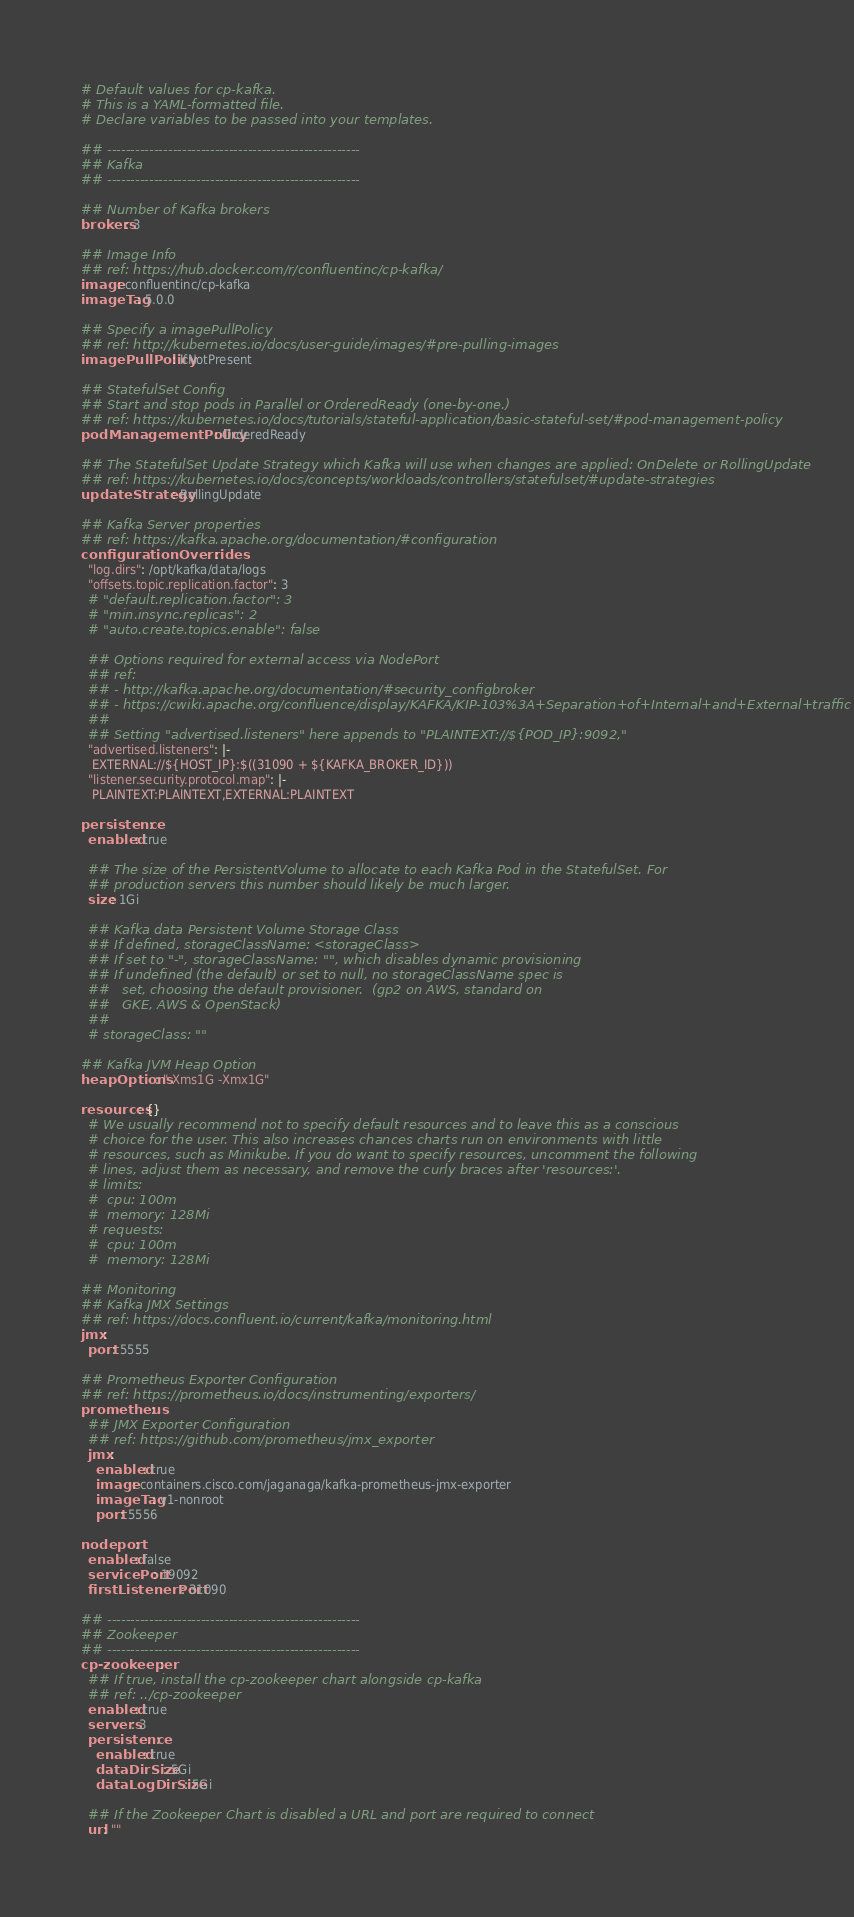<code> <loc_0><loc_0><loc_500><loc_500><_YAML_># Default values for cp-kafka.
# This is a YAML-formatted file.
# Declare variables to be passed into your templates.

## ------------------------------------------------------
## Kafka
## ------------------------------------------------------

## Number of Kafka brokers
brokers: 3

## Image Info
## ref: https://hub.docker.com/r/confluentinc/cp-kafka/
image: confluentinc/cp-kafka
imageTag: 5.0.0

## Specify a imagePullPolicy
## ref: http://kubernetes.io/docs/user-guide/images/#pre-pulling-images
imagePullPolicy: IfNotPresent

## StatefulSet Config
## Start and stop pods in Parallel or OrderedReady (one-by-one.)
## ref: https://kubernetes.io/docs/tutorials/stateful-application/basic-stateful-set/#pod-management-policy
podManagementPolicy: OrderedReady

## The StatefulSet Update Strategy which Kafka will use when changes are applied: OnDelete or RollingUpdate
## ref: https://kubernetes.io/docs/concepts/workloads/controllers/statefulset/#update-strategies
updateStrategy: RollingUpdate

## Kafka Server properties
## ref: https://kafka.apache.org/documentation/#configuration
configurationOverrides:
  "log.dirs": /opt/kafka/data/logs
  "offsets.topic.replication.factor": 3
  # "default.replication.factor": 3
  # "min.insync.replicas": 2
  # "auto.create.topics.enable": false

  ## Options required for external access via NodePort
  ## ref:
  ## - http://kafka.apache.org/documentation/#security_configbroker
  ## - https://cwiki.apache.org/confluence/display/KAFKA/KIP-103%3A+Separation+of+Internal+and+External+traffic
  ##
  ## Setting "advertised.listeners" here appends to "PLAINTEXT://${POD_IP}:9092,"
  "advertised.listeners": |-
   EXTERNAL://${HOST_IP}:$((31090 + ${KAFKA_BROKER_ID}))
  "listener.security.protocol.map": |-
   PLAINTEXT:PLAINTEXT,EXTERNAL:PLAINTEXT

persistence:
  enabled: true

  ## The size of the PersistentVolume to allocate to each Kafka Pod in the StatefulSet. For
  ## production servers this number should likely be much larger.
  size: 1Gi

  ## Kafka data Persistent Volume Storage Class
  ## If defined, storageClassName: <storageClass>
  ## If set to "-", storageClassName: "", which disables dynamic provisioning
  ## If undefined (the default) or set to null, no storageClassName spec is
  ##   set, choosing the default provisioner.  (gp2 on AWS, standard on
  ##   GKE, AWS & OpenStack)
  ##
  # storageClass: ""

## Kafka JVM Heap Option
heapOptions: "-Xms1G -Xmx1G"

resources: {}
  # We usually recommend not to specify default resources and to leave this as a conscious
  # choice for the user. This also increases chances charts run on environments with little
  # resources, such as Minikube. If you do want to specify resources, uncomment the following
  # lines, adjust them as necessary, and remove the curly braces after 'resources:'.
  # limits:
  #  cpu: 100m
  #  memory: 128Mi
  # requests:
  #  cpu: 100m
  #  memory: 128Mi

## Monitoring
## Kafka JMX Settings
## ref: https://docs.confluent.io/current/kafka/monitoring.html
jmx:
  port: 5555

## Prometheus Exporter Configuration
## ref: https://prometheus.io/docs/instrumenting/exporters/
prometheus:
  ## JMX Exporter Configuration
  ## ref: https://github.com/prometheus/jmx_exporter
  jmx:
    enabled: true
    image: containers.cisco.com/jaganaga/kafka-prometheus-jmx-exporter
    imageTag: v1-nonroot
    port: 5556

nodeport:
  enabled: false
  servicePort: 19092
  firstListenerPort: 31090

## ------------------------------------------------------
## Zookeeper
## ------------------------------------------------------
cp-zookeeper:
  ## If true, install the cp-zookeeper chart alongside cp-kafka
  ## ref: ../cp-zookeeper
  enabled: true
  servers: 3
  persistence:
    enabled: true
    dataDirSize: 5Gi
    dataLogDirSize: 5Gi

  ## If the Zookeeper Chart is disabled a URL and port are required to connect
  url: ""
</code> 